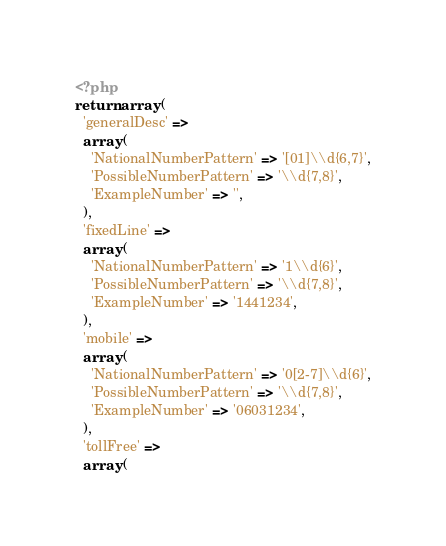<code> <loc_0><loc_0><loc_500><loc_500><_PHP_><?php
return array (
  'generalDesc' => 
  array (
    'NationalNumberPattern' => '[01]\\d{6,7}',
    'PossibleNumberPattern' => '\\d{7,8}',
    'ExampleNumber' => '',
  ),
  'fixedLine' => 
  array (
    'NationalNumberPattern' => '1\\d{6}',
    'PossibleNumberPattern' => '\\d{7,8}',
    'ExampleNumber' => '1441234',
  ),
  'mobile' => 
  array (
    'NationalNumberPattern' => '0[2-7]\\d{6}',
    'PossibleNumberPattern' => '\\d{7,8}',
    'ExampleNumber' => '06031234',
  ),
  'tollFree' => 
  array (</code> 